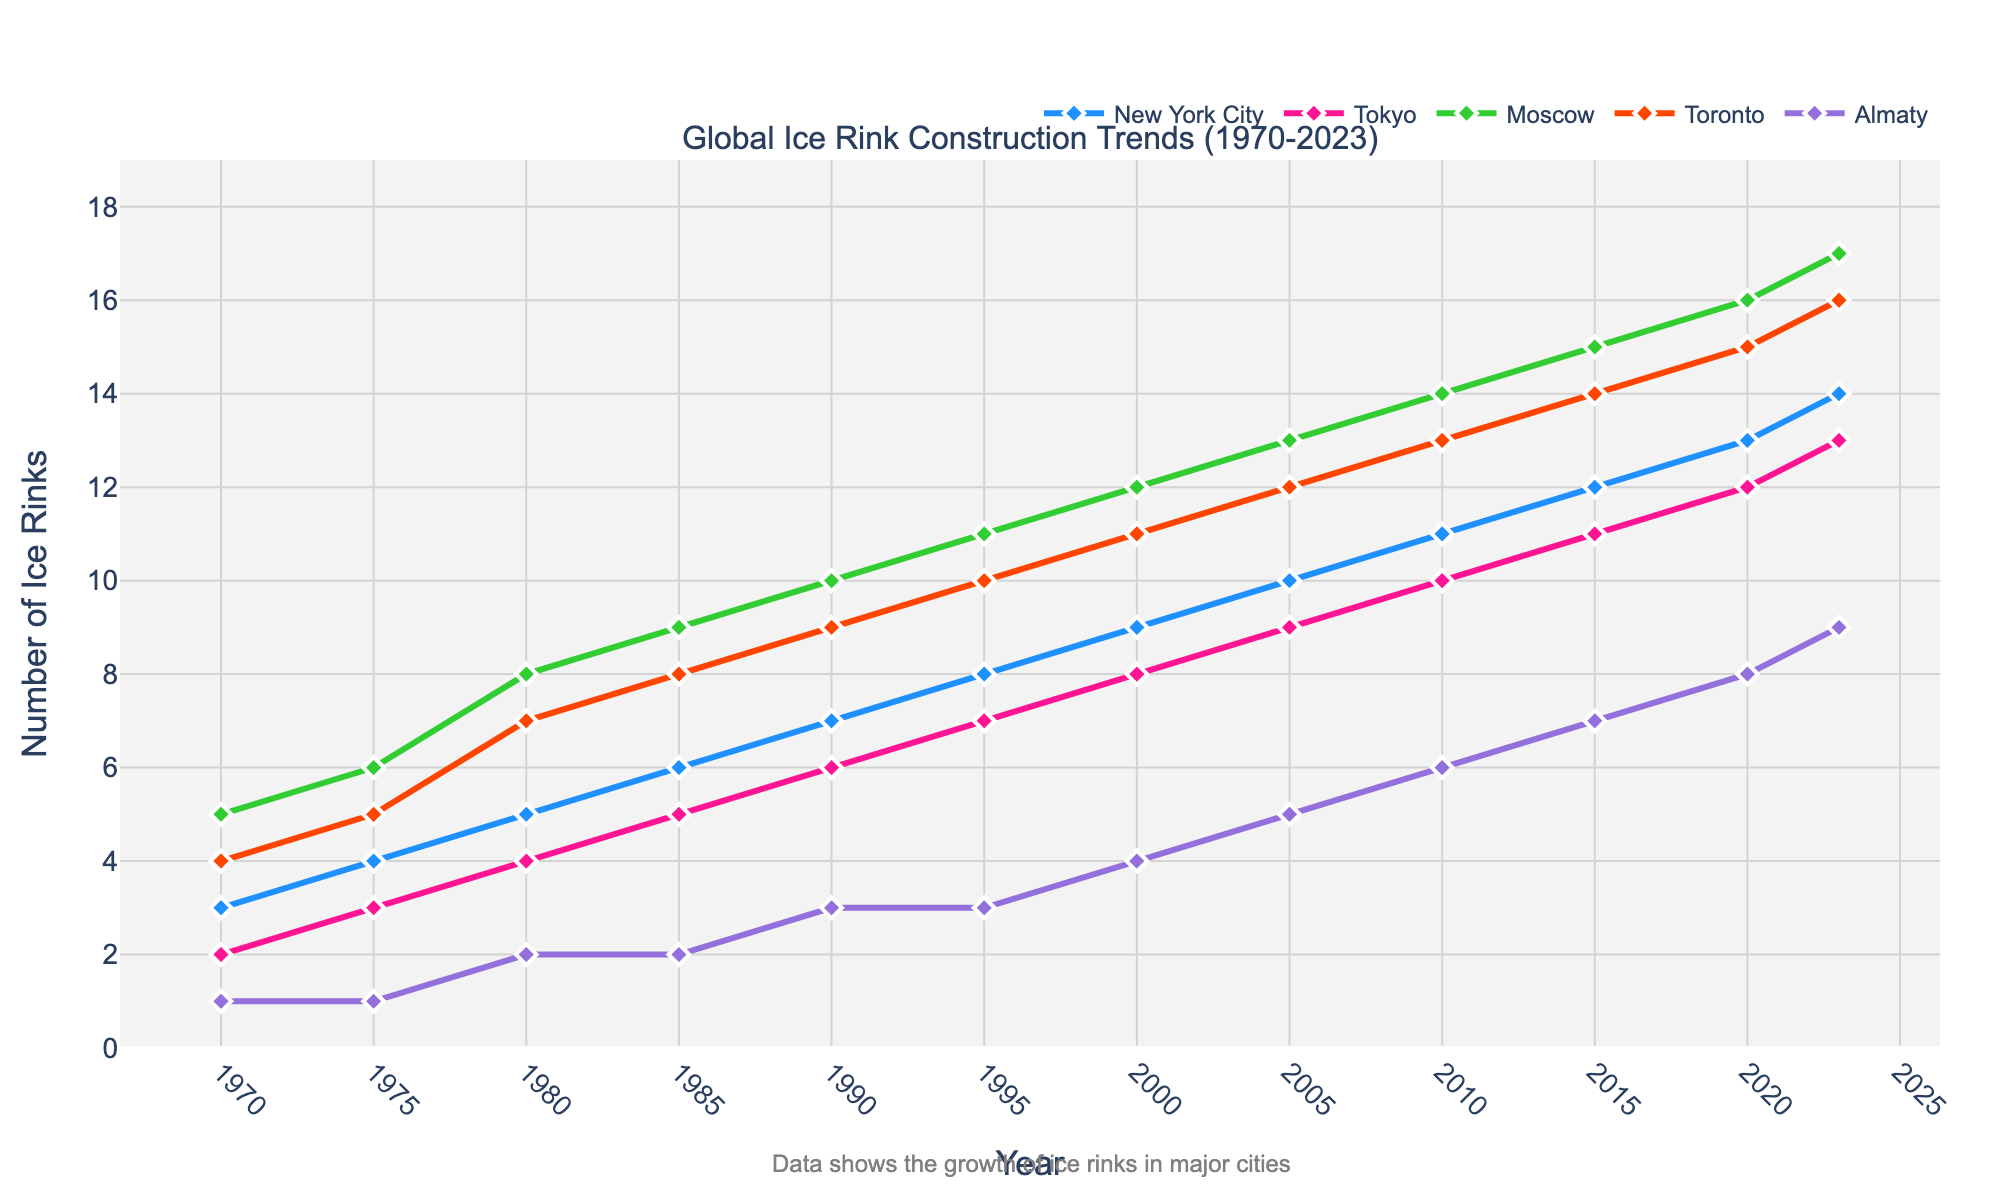How many new ice rinks were constructed in Almaty between 1995 and 2005? To find the number of new ice rinks constructed, subtract the 1995 value from the 2005 value for Almaty. That is, 5 (in 2005) - 3 (in 1995) = 2.
Answer: 2 Which city had the highest number of ice rinks constructed by 2023? By looking at the values for each city in 2023, Moscow had the highest number of ice rinks with 17.
Answer: Moscow What is the difference in the number of ice rinks between Tokyo and Toronto in 2010? To find the difference, subtract the number of ice rinks in Tokyo from that in Toronto in 2010. That is, 13 (Toronto) - 10 (Tokyo) = 3.
Answer: 3 Which city saw the most significant increase in the number of ice rinks from 1970 to 2023? Calculate the increase for each city by subtracting their 1970 values from their 2023 values. Moscow's increase is 17 - 5 = 12, which is the highest among all cities.
Answer: Moscow What is the total number of ice rinks across all cities in the year 2000? Sum the number of ice rinks in each city for the year 2000. That is, 9 (NYC) + 8 (Tokyo) + 12 (Moscow) + 11 (Toronto) + 4 (Almaty) = 44.
Answer: 44 Between which two consecutive five-year periods did New York City experience the highest increase in ice rinks? Calculate the difference between consecutive five-year periods for NYC. The highest increase is between 1985 and 1990, where the number rose from 6 to 7, an increase of 1 (but all periods have the same difference of 1).
Answer: Any consecutive five-year period (same difference) How does the number of ice rinks in Almaty in 2023 compare to that in 2010? Compare the values directly: 9 (2023) is greater than 6 (2010), so the number of rinks in Almaty increased.
Answer: Increased If the trend continues, in which year will Tokyo likely surpass New York City in the number of ice rinks? Tokyo and NYC have increasing trends, but NYC has more rinks than Tokyo each year. Based on the trend shown, Tokyo might not surpass NYC if the trend continues similarly.
Answer: Not likely to surpass Which city showed the least growth in the number of ice rinks from 1970 to 2023? Calculate the increase for each city by subtracting their 1970 values from their 2023 values. Almaty increased by 9 - 1 = 8, which is the least growth among all cities.
Answer: Almaty Comparing 1980 and 2020, how much did the ratio of ice rinks between Moscow and New York City change? Calculate the ratios for both years. In 1980, the ratio is 8 (Moscow) / 5 (NYC) = 1.6. In 2020, the ratio is 16 (Moscow) / 13 (NYC) ≈ 1.23. The change is 1.6 - 1.23 = 0.37.
Answer: 0.37 